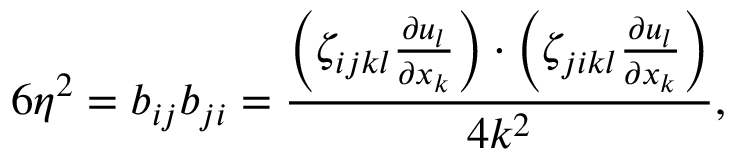Convert formula to latex. <formula><loc_0><loc_0><loc_500><loc_500>6 \eta ^ { 2 } = b _ { i j } b _ { j i } = \frac { \left ( \zeta _ { i j k l } \frac { \partial u _ { l } } { \partial x _ { k } } \right ) \cdot \left ( \zeta _ { j i k l } \frac { \partial u _ { l } } { \partial x _ { k } } \right ) } { 4 k ^ { 2 } } ,</formula> 